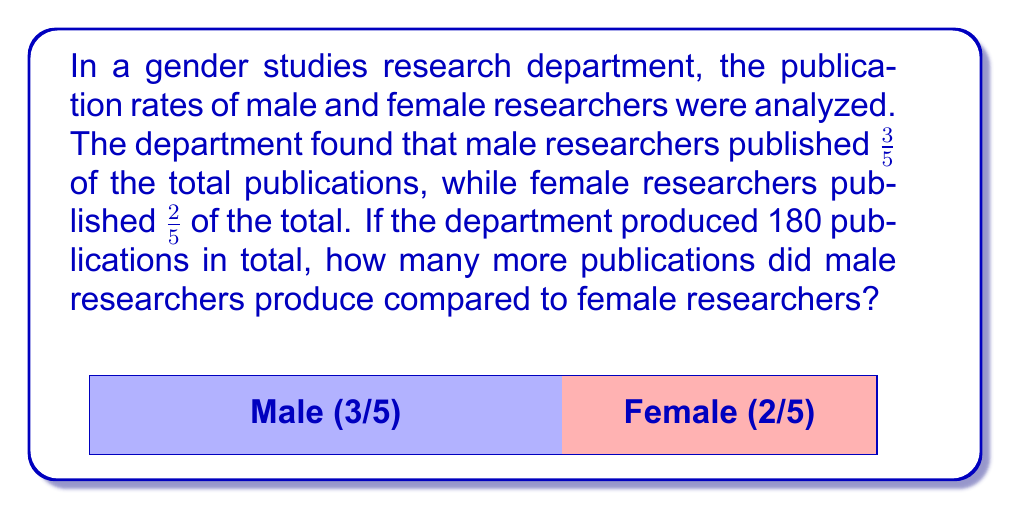Teach me how to tackle this problem. Let's approach this step-by-step:

1) First, we need to calculate the number of publications for each group:

   Male researchers: $\frac{3}{5} \times 180 = 108$ publications
   Female researchers: $\frac{2}{5} \times 180 = 72$ publications

2) To find how many more publications male researchers produced, we subtract:

   $108 - 72 = 36$

3) We can verify this result by checking if it matches the original fractions:

   Male publications: $108 = \frac{3}{5} \times 180$
   Female publications: $72 = \frac{2}{5} \times 180$
   Difference: $36 = \frac{1}{5} \times 180$

This aligns with our expectation, as $\frac{3}{5} - \frac{2}{5} = \frac{1}{5}$

Therefore, male researchers produced 36 more publications than female researchers.
Answer: 36 publications 